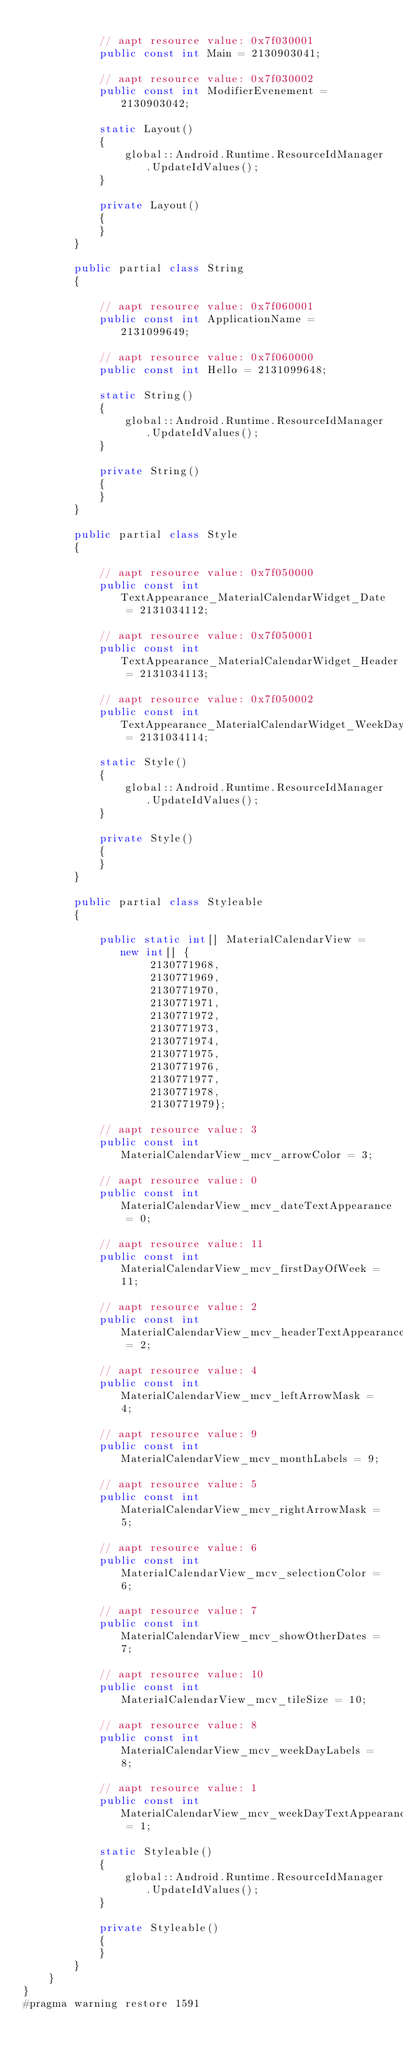<code> <loc_0><loc_0><loc_500><loc_500><_C#_>			
			// aapt resource value: 0x7f030001
			public const int Main = 2130903041;
			
			// aapt resource value: 0x7f030002
			public const int ModifierEvenement = 2130903042;
			
			static Layout()
			{
				global::Android.Runtime.ResourceIdManager.UpdateIdValues();
			}
			
			private Layout()
			{
			}
		}
		
		public partial class String
		{
			
			// aapt resource value: 0x7f060001
			public const int ApplicationName = 2131099649;
			
			// aapt resource value: 0x7f060000
			public const int Hello = 2131099648;
			
			static String()
			{
				global::Android.Runtime.ResourceIdManager.UpdateIdValues();
			}
			
			private String()
			{
			}
		}
		
		public partial class Style
		{
			
			// aapt resource value: 0x7f050000
			public const int TextAppearance_MaterialCalendarWidget_Date = 2131034112;
			
			// aapt resource value: 0x7f050001
			public const int TextAppearance_MaterialCalendarWidget_Header = 2131034113;
			
			// aapt resource value: 0x7f050002
			public const int TextAppearance_MaterialCalendarWidget_WeekDay = 2131034114;
			
			static Style()
			{
				global::Android.Runtime.ResourceIdManager.UpdateIdValues();
			}
			
			private Style()
			{
			}
		}
		
		public partial class Styleable
		{
			
			public static int[] MaterialCalendarView = new int[] {
					2130771968,
					2130771969,
					2130771970,
					2130771971,
					2130771972,
					2130771973,
					2130771974,
					2130771975,
					2130771976,
					2130771977,
					2130771978,
					2130771979};
			
			// aapt resource value: 3
			public const int MaterialCalendarView_mcv_arrowColor = 3;
			
			// aapt resource value: 0
			public const int MaterialCalendarView_mcv_dateTextAppearance = 0;
			
			// aapt resource value: 11
			public const int MaterialCalendarView_mcv_firstDayOfWeek = 11;
			
			// aapt resource value: 2
			public const int MaterialCalendarView_mcv_headerTextAppearance = 2;
			
			// aapt resource value: 4
			public const int MaterialCalendarView_mcv_leftArrowMask = 4;
			
			// aapt resource value: 9
			public const int MaterialCalendarView_mcv_monthLabels = 9;
			
			// aapt resource value: 5
			public const int MaterialCalendarView_mcv_rightArrowMask = 5;
			
			// aapt resource value: 6
			public const int MaterialCalendarView_mcv_selectionColor = 6;
			
			// aapt resource value: 7
			public const int MaterialCalendarView_mcv_showOtherDates = 7;
			
			// aapt resource value: 10
			public const int MaterialCalendarView_mcv_tileSize = 10;
			
			// aapt resource value: 8
			public const int MaterialCalendarView_mcv_weekDayLabels = 8;
			
			// aapt resource value: 1
			public const int MaterialCalendarView_mcv_weekDayTextAppearance = 1;
			
			static Styleable()
			{
				global::Android.Runtime.ResourceIdManager.UpdateIdValues();
			}
			
			private Styleable()
			{
			}
		}
	}
}
#pragma warning restore 1591
</code> 